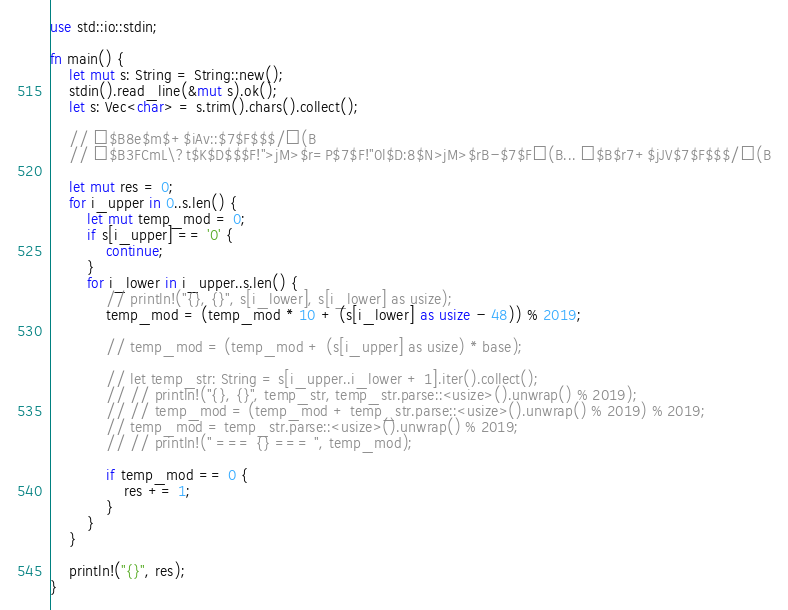Convert code to text. <code><loc_0><loc_0><loc_500><loc_500><_Rust_>use std::io::stdin;

fn main() {
    let mut s: String = String::new();
    stdin().read_line(&mut s).ok();
    let s: Vec<char> = s.trim().chars().collect();

    // $B8e$m$+$iAv::$7$F$$$/(B
    // $B3FCmL\?t$K$D$$$F!">jM>$r=P$7$F!"0l$D:8$N>jM>$rB-$7$F(B... $B$r7+$jJV$7$F$$$/(B

    let mut res = 0;
    for i_upper in 0..s.len() {
        let mut temp_mod = 0;
        if s[i_upper] == '0' {
            continue;
        }
        for i_lower in i_upper..s.len() {
            // println!("{}, {}", s[i_lower], s[i_lower] as usize);
            temp_mod = (temp_mod * 10 + (s[i_lower] as usize - 48)) % 2019;

            // temp_mod = (temp_mod + (s[i_upper] as usize) * base);

            // let temp_str: String = s[i_upper..i_lower + 1].iter().collect();
            // // println!("{}, {}", temp_str, temp_str.parse::<usize>().unwrap() % 2019);
            // // temp_mod = (temp_mod + temp_str.parse::<usize>().unwrap() % 2019) % 2019;
            // temp_mod = temp_str.parse::<usize>().unwrap() % 2019;
            // // println!(" === {} === ", temp_mod);

            if temp_mod == 0 {
                res += 1;
            }
        }
    }

    println!("{}", res);
}
</code> 